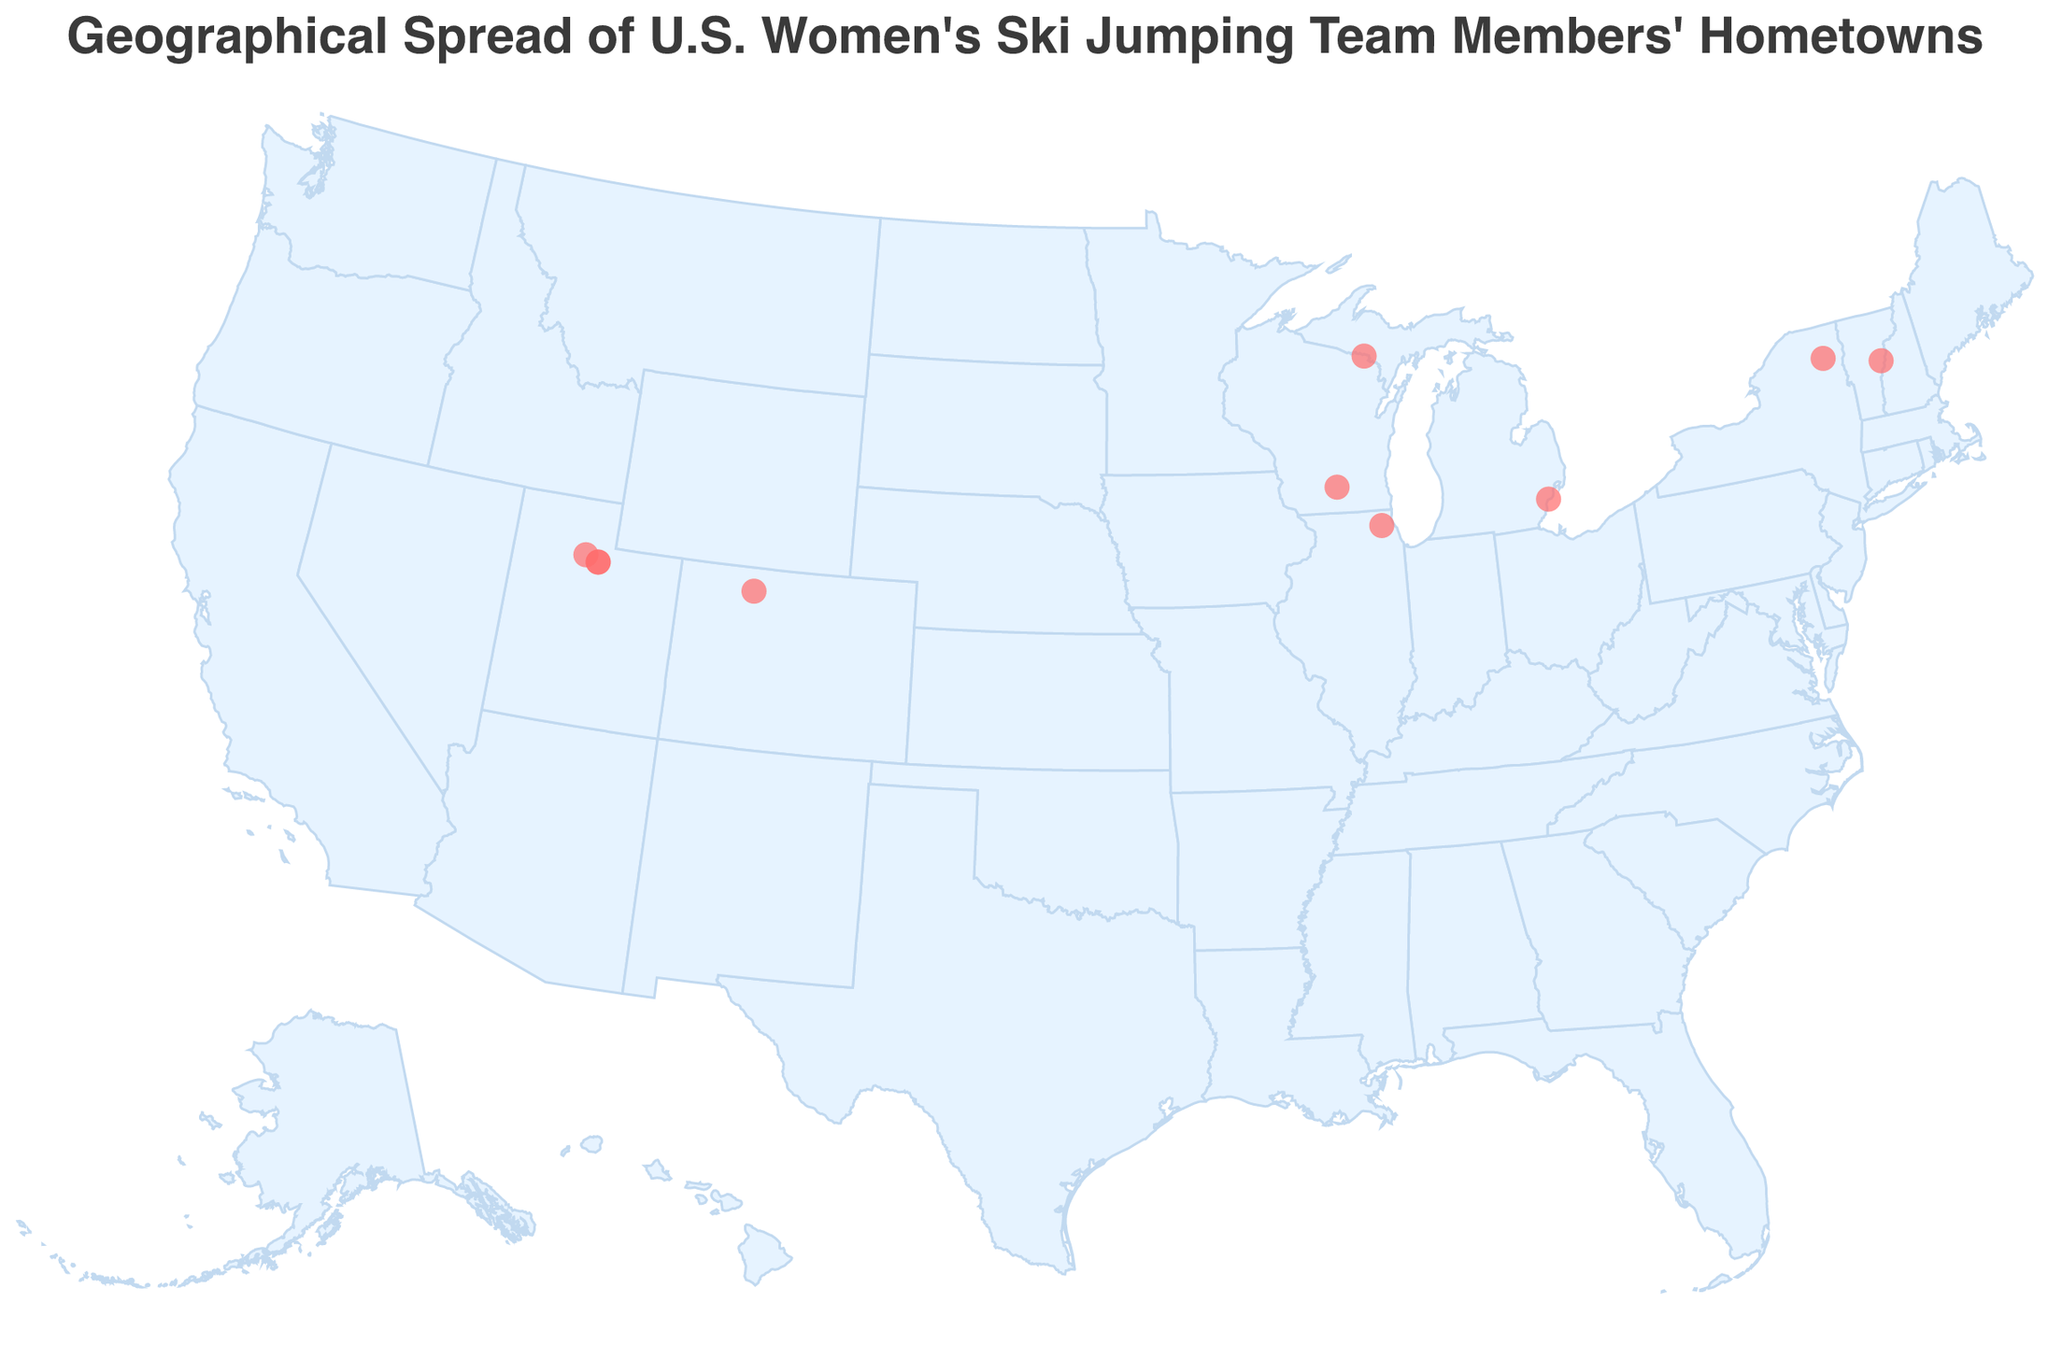What is the title of the figure? The title of a figure is typically shown at the top and is used to summarize or explain the content of the plot. In this case, the title is clearly visible at the top in a larger font size.
Answer: Geographical Spread of U.S. Women's Ski Jumping Team Members' Hometowns How many athletes are shown on the map? The number of circles on the map corresponds to the number of athletes. By counting them, we can determine the number of athletes represented.
Answer: 10 Which state has the highest number of athletes? By observing the count of circles in each state, Utah has the most circles, which indicates it has the highest number of athletes.
Answer: Utah Are there any athletes from the state of Colorado? The color-coded circle locations on the map can be identified by their state locations. One of the circles is indeed in Colorado.
Answer: Yes Who are the athletes from Park City, Utah? By looking at the tooltip information for the circles in Park City, Utah, we can see the names of the athletes associated with those coordinates.
Answer: Sarah Hendrickson and Jessica Jerome What is the range of latitudes covered by the athletes' hometowns? By examining the latitude values of the circles on the map, we determine the range from the northernmost point (45.9219) to the southernmost point (40.4850).
Answer: 40.4850 to 45.9219 How many states in total are represented by the athletes’ hometowns? Observing the different states mentioned in the tooltips or labels of the circles will give us the count of unique states.
Answer: 8 Which athlete's hometown is the easternmost point on the map? By comparing the longitudes, the easternmost point (with the smallest value) corresponds to an athlete's hometown in Vermont.
Answer: Tara Geraghty-Moats Compare the number of athletes from Wisconsin and Utah. How many more athletes are there in the higher state? Count the number of circles in Wisconsin and Utah respectively, then subtract the smaller count from the larger one. Utah has 3 athletes while Wisconsin has 2 athletes. 3 - 2 = 1
Answer: 1 How many athletes are from states on the East Coast? By identifying which states are located on the East Coast (New York and Vermont) and counting the athletes from those states, we get the total number. There are athletes from New York and Vermont, hence 1 each. 1 + 1 = 2.
Answer: 2 